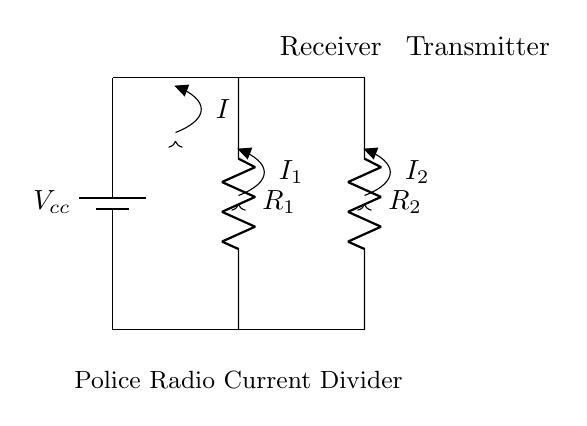What is the supply voltage in this circuit? The supply voltage, denoted as Vcc, is indicated at the battery terminal in the diagram. Without any numerical value provided directly in the circuit, we assume it would be standard for such applications.
Answer: Vcc What are the components used in this current divider? The components shown are a battery (representing the power supply), two resistors (R1 for the receiver and R2 for the transmitter), and arrows indicating current paths.
Answer: Battery, R1, R2 What is the current entering the circuit? The total current entering the circuit is denoted as I, which flows from the voltage source through R1 and R2 in parallel. It is the current coming from the battery into the circuit.
Answer: I How is the current distributed between the receiver and transmitter? The current is divided according to the resistances in the circuit. According to the current divider rule, the lower the resistance, the higher the current flows through it. The currents I1 and I2 split from I based on R1 and R2.
Answer: I1 and I2 Which component has a greater power consumption, R1 or R2? To find out which resistor consumes more power, we compare their values. The one with the lower resistance (if R1 < R2, then I1 > I2) has a higher current and thus greater power consumption according to the formula P = I^2R.
Answer: Depends on R1 and R2 What is the purpose of a current divider in a police radio? A current divider is used to efficiently distribute current between the different components (receiver and transmitter) of the radio system, optimizing performance and ensuring that each component receives the appropriate amount of current for its operation.
Answer: Distribute current 